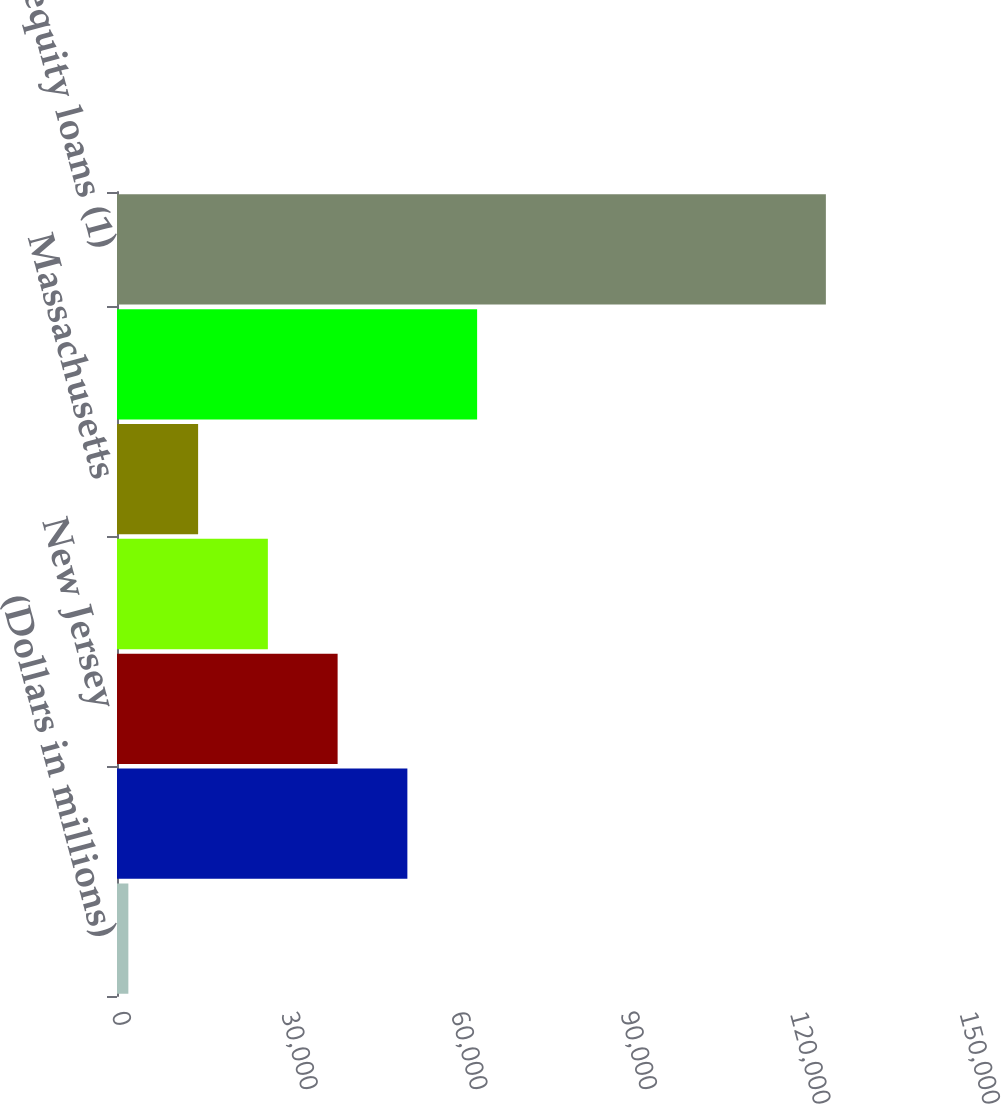Convert chart to OTSL. <chart><loc_0><loc_0><loc_500><loc_500><bar_chart><fcel>(Dollars in millions)<fcel>Florida<fcel>New Jersey<fcel>New York<fcel>Massachusetts<fcel>Other US/Non-US<fcel>Total home equity loans (1)<nl><fcel>2010<fcel>51362.4<fcel>39024.3<fcel>26686.2<fcel>14348.1<fcel>63700.5<fcel>125391<nl></chart> 